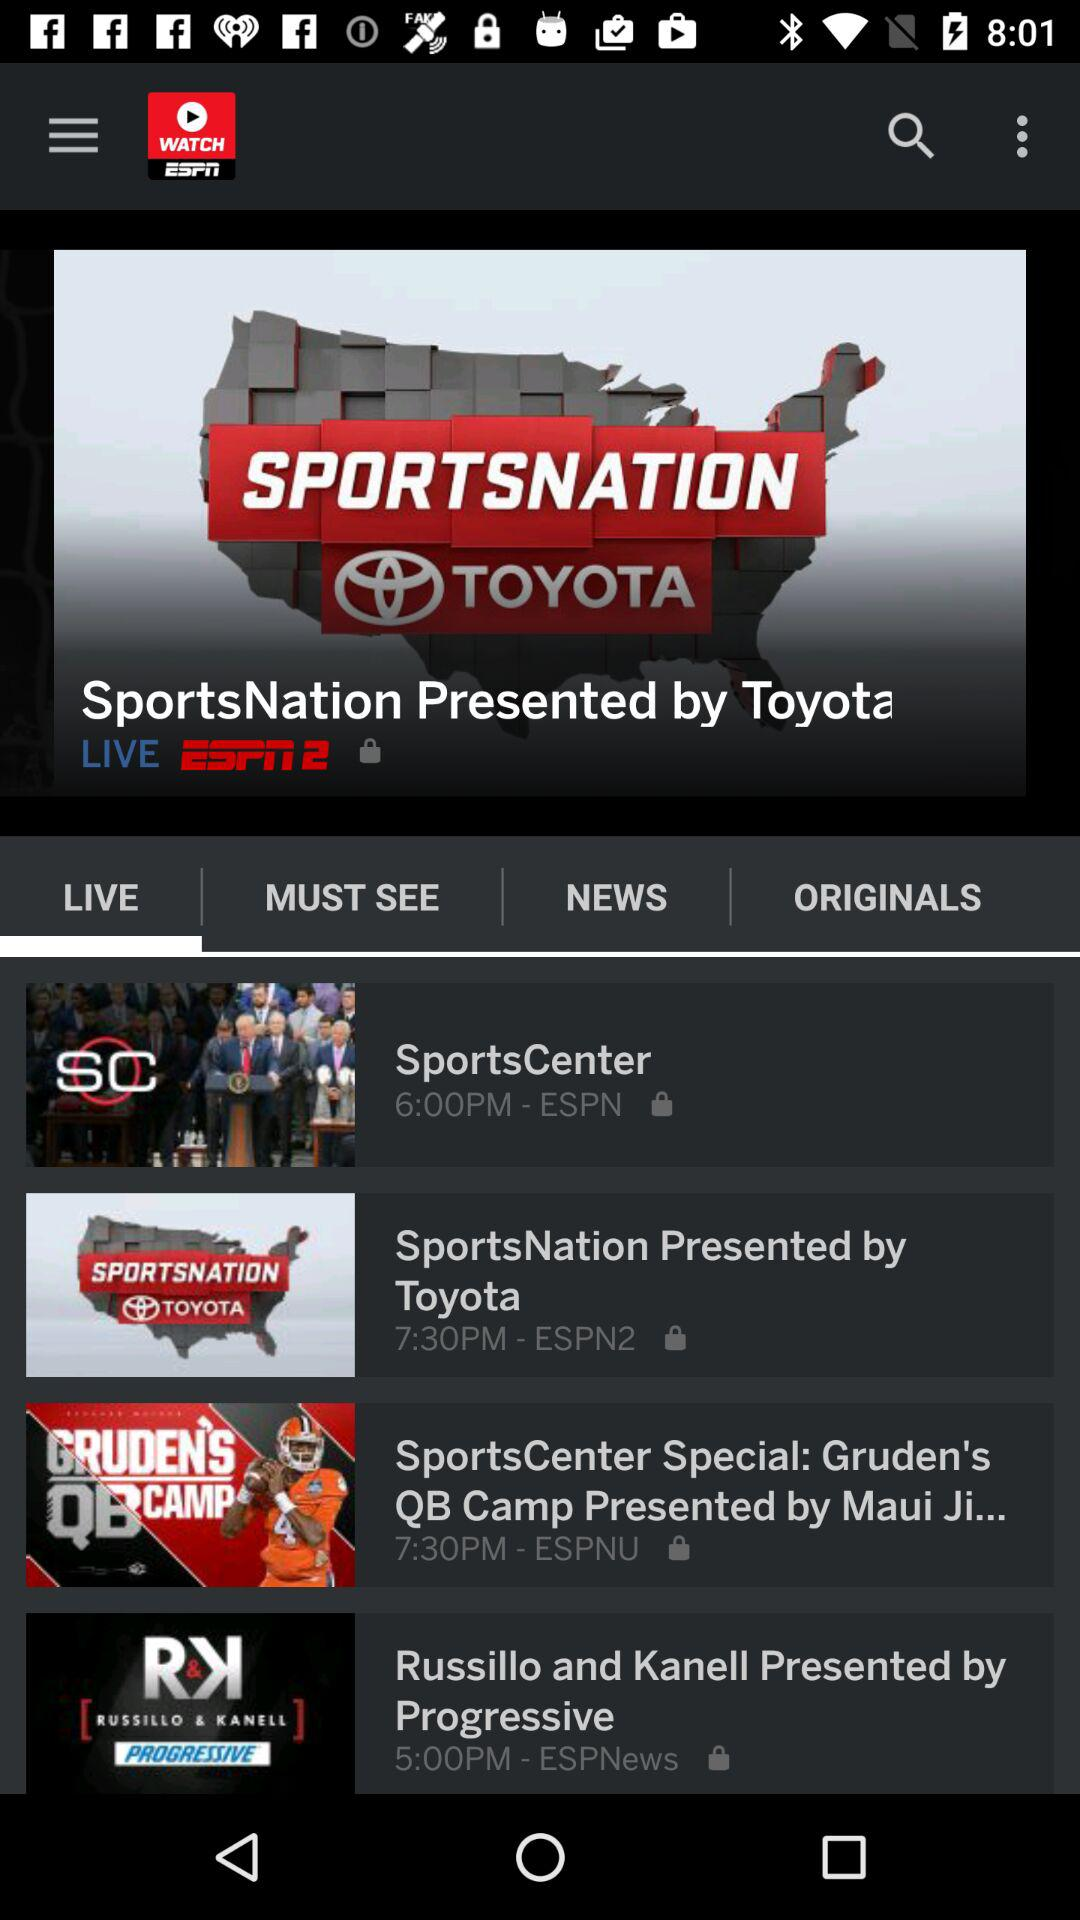At what time does "SportsCenter" air? "SportsCenter" airs at 6:00 p.m. 